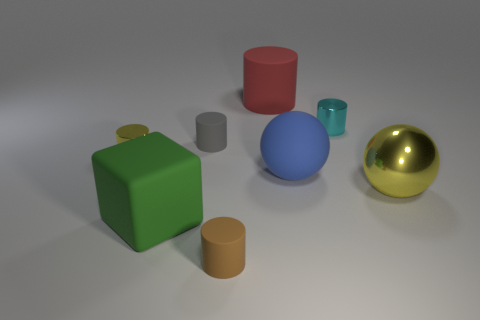What number of things are either blue things or large blocks?
Provide a succinct answer. 2. Does the red object have the same shape as the big green matte thing?
Make the answer very short. No. What is the material of the green object?
Your answer should be very brief. Rubber. How many big things are both in front of the blue matte ball and left of the big shiny sphere?
Your response must be concise. 1. Do the yellow metal cylinder and the cyan cylinder have the same size?
Give a very brief answer. Yes. Does the sphere on the right side of the blue sphere have the same size as the green thing?
Make the answer very short. Yes. There is a small rubber thing that is right of the tiny gray matte object; what is its color?
Make the answer very short. Brown. What number of small gray objects are there?
Offer a very short reply. 1. What is the shape of the large blue object that is the same material as the big cylinder?
Your response must be concise. Sphere. Do the large matte thing in front of the big metallic object and the tiny rubber cylinder in front of the tiny yellow thing have the same color?
Provide a succinct answer. No. 